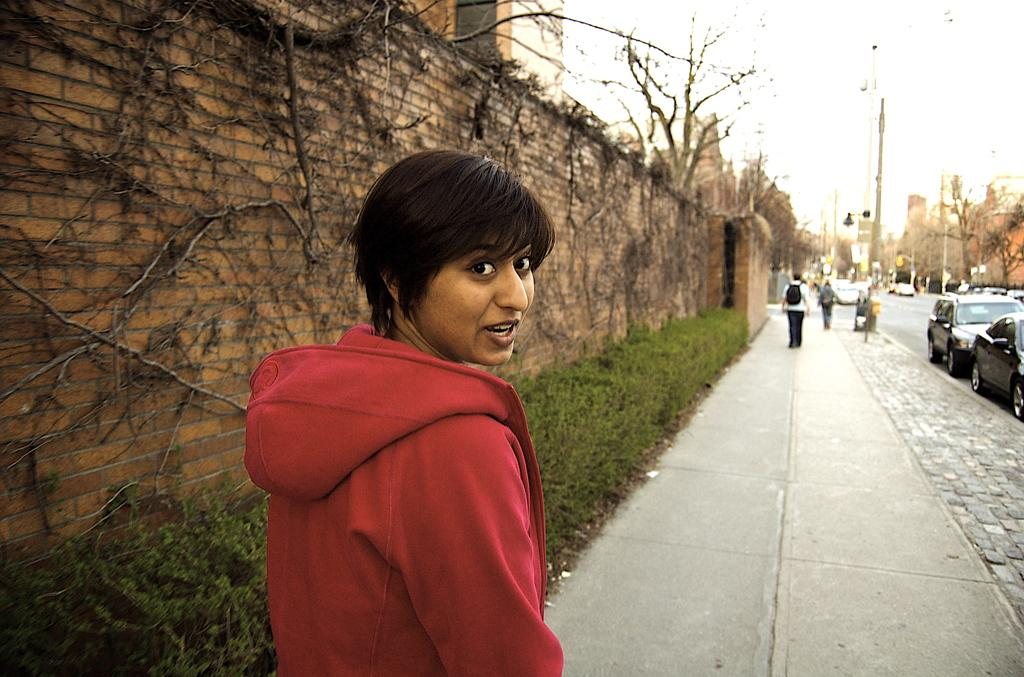Who or what can be seen in the image? There are people in the image. What is the background of the image? There is a wall, buildings, plants, and trees visible in the image. What is the setting of the image? The image shows a scene with people, buildings, and vehicles on the road. What other objects can be seen in the image? Light poles are present in the image. What is visible in the sky? The sky is visible in the image. What type of tub is being used for the distribution of water in the image? There is no tub or water distribution system present in the image. 